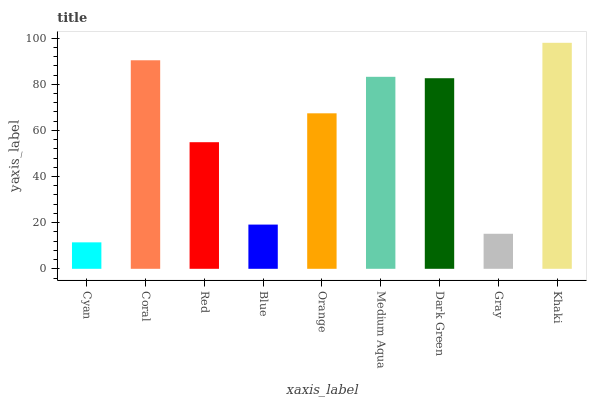Is Coral the minimum?
Answer yes or no. No. Is Coral the maximum?
Answer yes or no. No. Is Coral greater than Cyan?
Answer yes or no. Yes. Is Cyan less than Coral?
Answer yes or no. Yes. Is Cyan greater than Coral?
Answer yes or no. No. Is Coral less than Cyan?
Answer yes or no. No. Is Orange the high median?
Answer yes or no. Yes. Is Orange the low median?
Answer yes or no. Yes. Is Cyan the high median?
Answer yes or no. No. Is Khaki the low median?
Answer yes or no. No. 